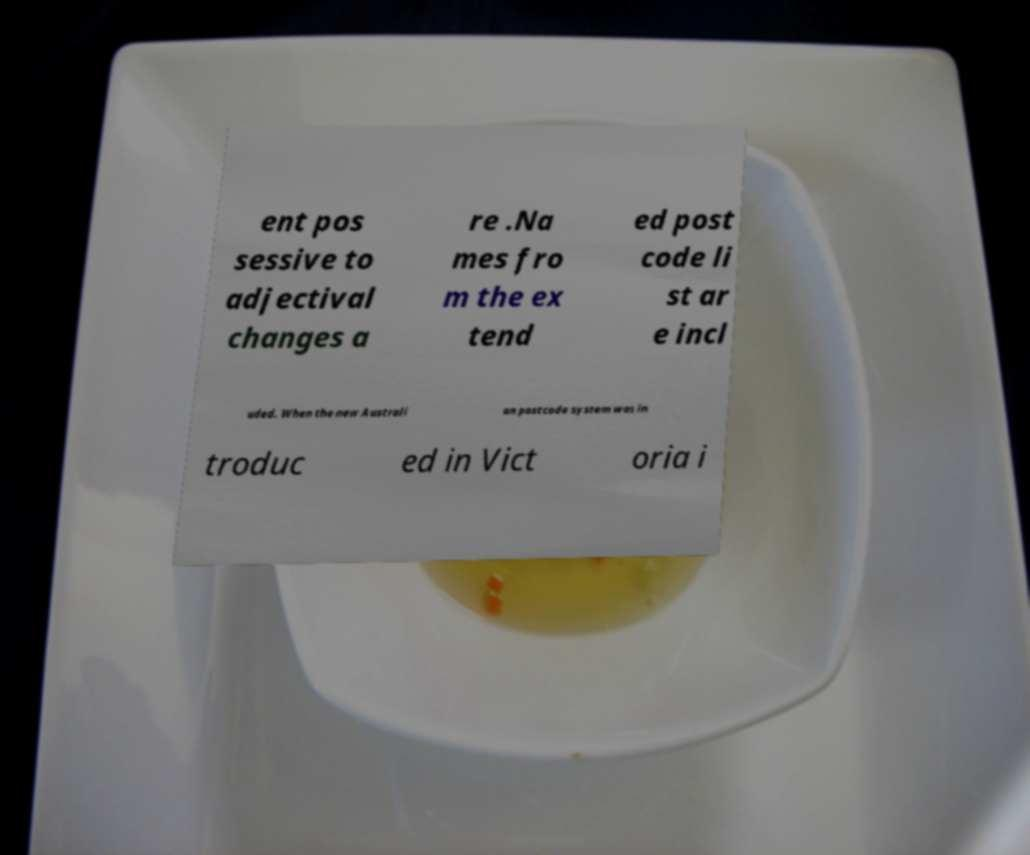I need the written content from this picture converted into text. Can you do that? ent pos sessive to adjectival changes a re .Na mes fro m the ex tend ed post code li st ar e incl uded. When the new Australi an postcode system was in troduc ed in Vict oria i 